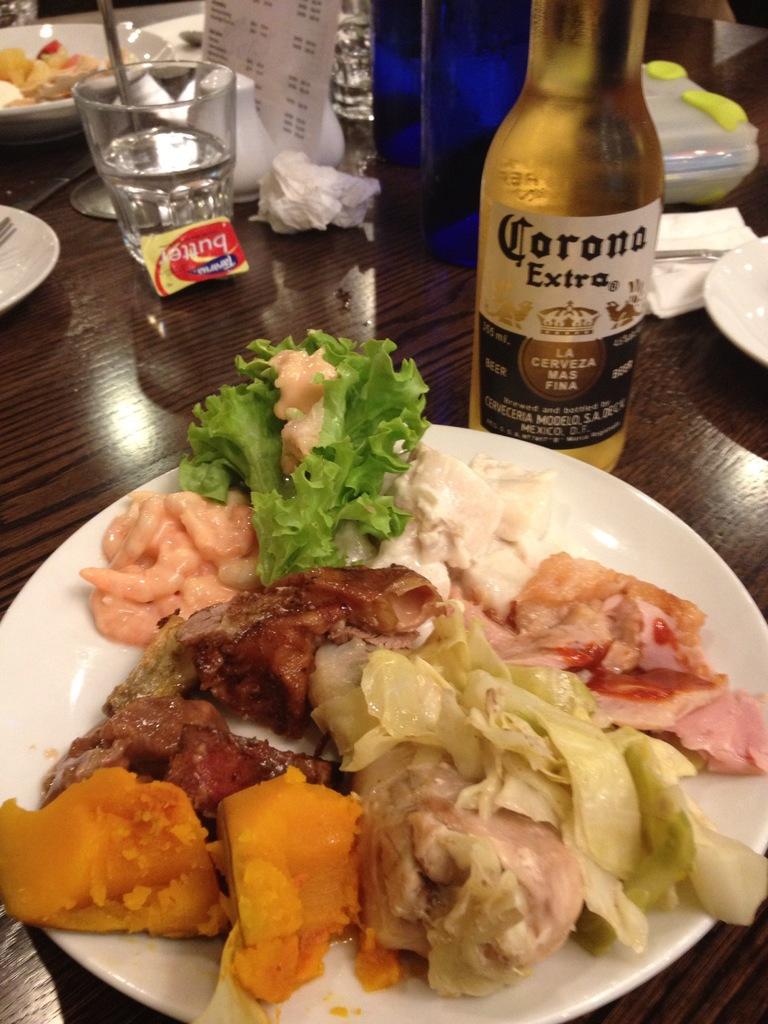What type of beer is this?
Your answer should be compact. Corona extra. 